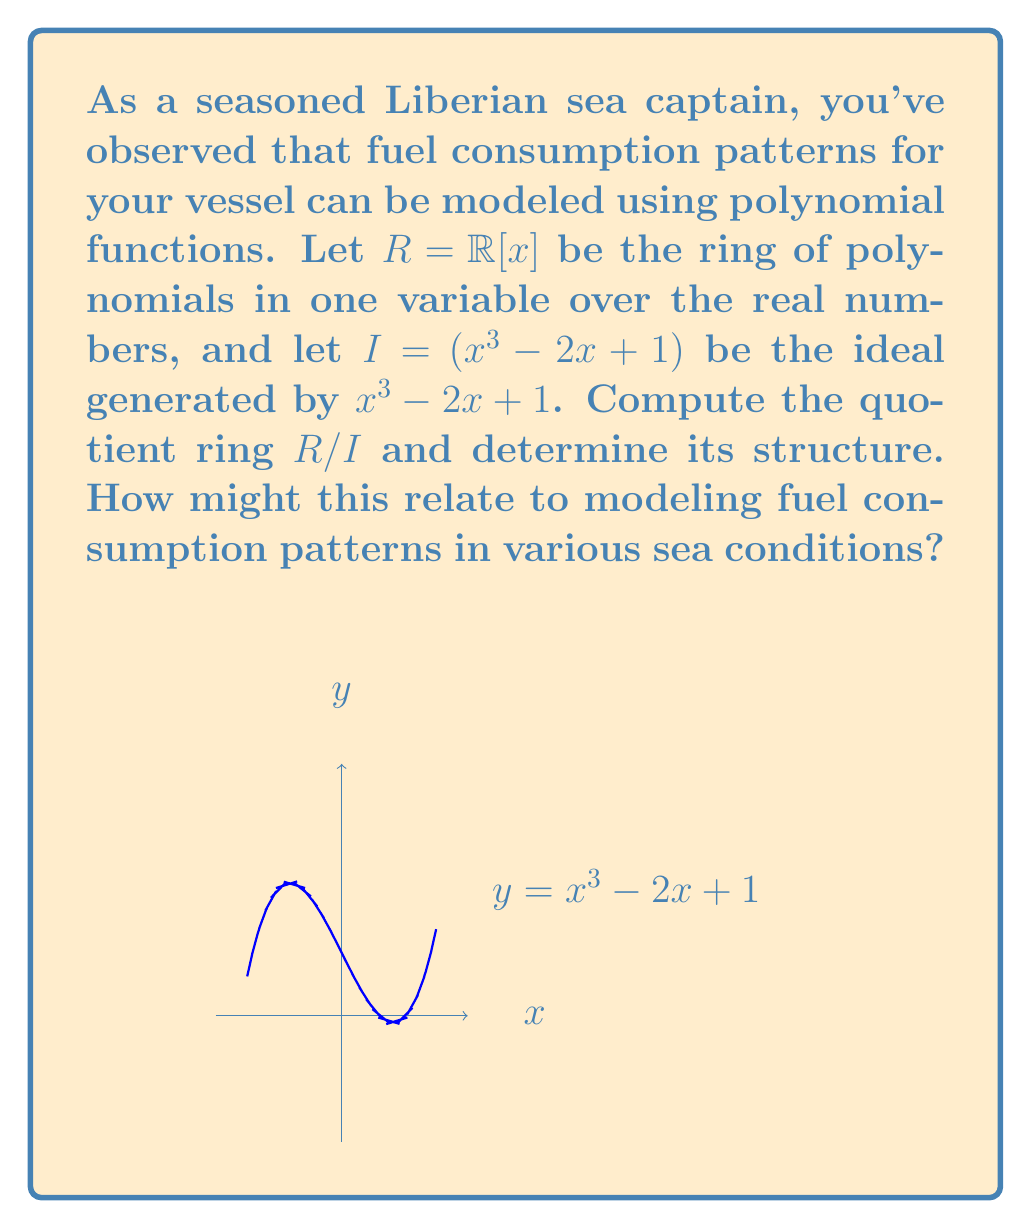Help me with this question. Let's approach this step-by-step:

1) The quotient ring $R/I$ consists of equivalence classes of polynomials modulo the ideal $I = (x^3 - 2x + 1)$.

2) Any polynomial $f(x) \in R$ can be written as:
   $f(x) = q(x)(x^3 - 2x + 1) + r(x)$
   where $\deg(r) < 3$ (by the polynomial division algorithm).

3) This means that every element in $R/I$ can be represented uniquely by a polynomial of degree at most 2.

4) Therefore, $R/I$ is isomorphic to the vector space of polynomials of degree at most 2:
   $R/I \cong \{ax^2 + bx + c \mid a,b,c \in \mathbb{R}\}$

5) As a ring, $R/I$ has addition and multiplication defined modulo $x^3 - 2x + 1$.

6) The dimension of this vector space is 3, with basis $\{1, x, x^2\}$.

Relating to fuel consumption:
- The quotient ring structure allows us to model cyclic patterns in fuel consumption.
- The polynomial $x^3 - 2x + 1$ might represent a complex relationship between speed, distance, and fuel consumption.
- Working in $R/I$ allows us to simplify calculations by considering only polynomials up to degree 2, which could represent quadratic approximations of more complex fuel consumption patterns.
- Different sea conditions (calm, moderate, rough) could be modeled by different elements in $R/I$, allowing for efficient comparisons and calculations.
Answer: $R/I \cong \mathbb{R}[x]/(x^3 - 2x + 1) \cong \{ax^2 + bx + c \mid a,b,c \in \mathbb{R}\}$ 